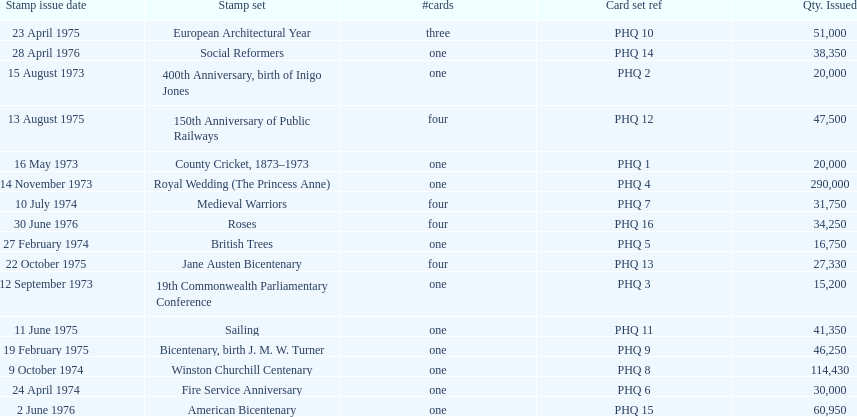How many stamp sets had at least 50,000 issued? 4. 